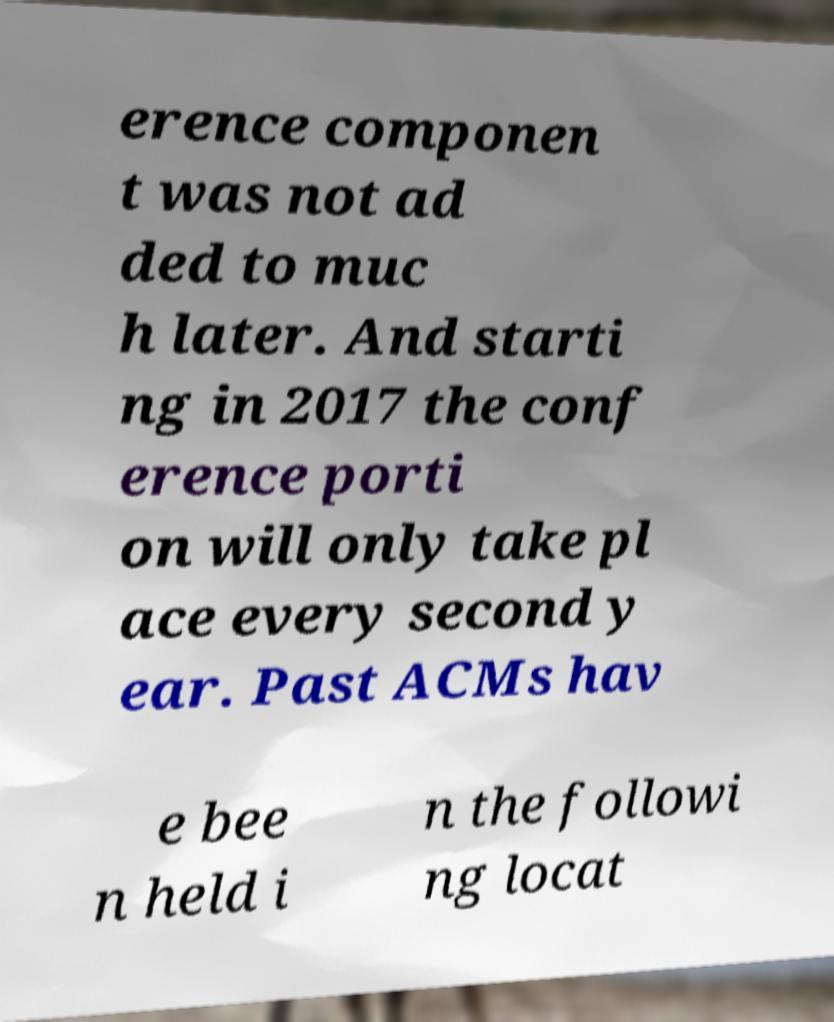I need the written content from this picture converted into text. Can you do that? erence componen t was not ad ded to muc h later. And starti ng in 2017 the conf erence porti on will only take pl ace every second y ear. Past ACMs hav e bee n held i n the followi ng locat 